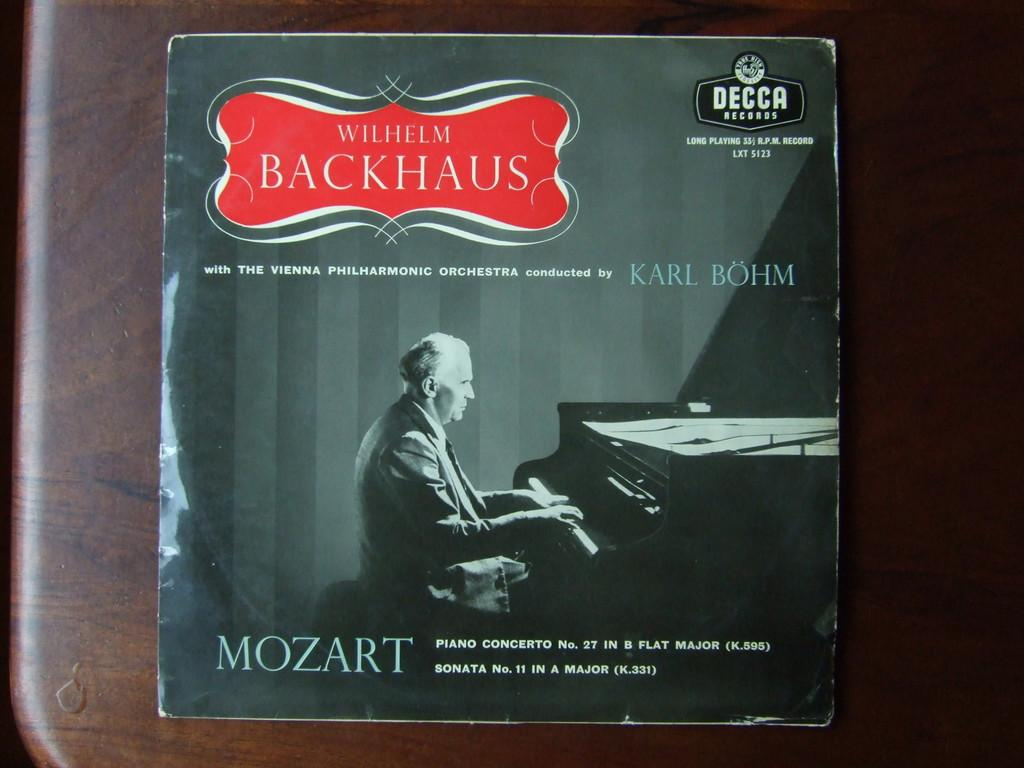<image>
Summarize the visual content of the image. A Mozart album with Wilhelm Backhaus sits on a table. 